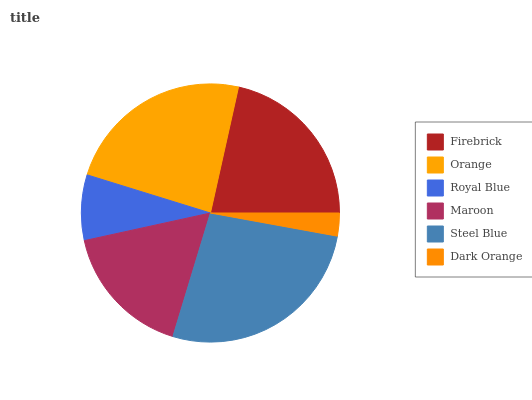Is Dark Orange the minimum?
Answer yes or no. Yes. Is Steel Blue the maximum?
Answer yes or no. Yes. Is Orange the minimum?
Answer yes or no. No. Is Orange the maximum?
Answer yes or no. No. Is Orange greater than Firebrick?
Answer yes or no. Yes. Is Firebrick less than Orange?
Answer yes or no. Yes. Is Firebrick greater than Orange?
Answer yes or no. No. Is Orange less than Firebrick?
Answer yes or no. No. Is Firebrick the high median?
Answer yes or no. Yes. Is Maroon the low median?
Answer yes or no. Yes. Is Maroon the high median?
Answer yes or no. No. Is Dark Orange the low median?
Answer yes or no. No. 